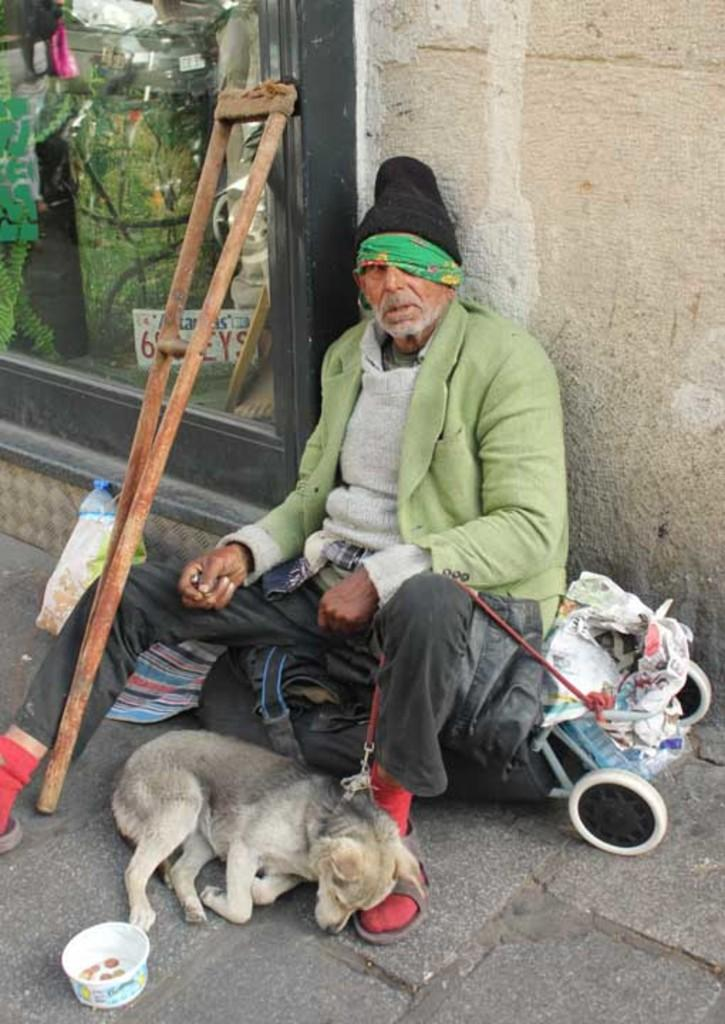Who is present in the image? There is a man in the image. What animal is near the man? There is a dog near the man. Where are they located? They are on a path. What objects can be seen in the image? There is a bowl and a stick in the image. What structure is visible in the image? There is a wall in the image. What year is depicted in the image? The image does not depict a specific year; it is a photograph of a man, a dog, and their surroundings. How many crows are visible in the image? There are no crows present in the image. 